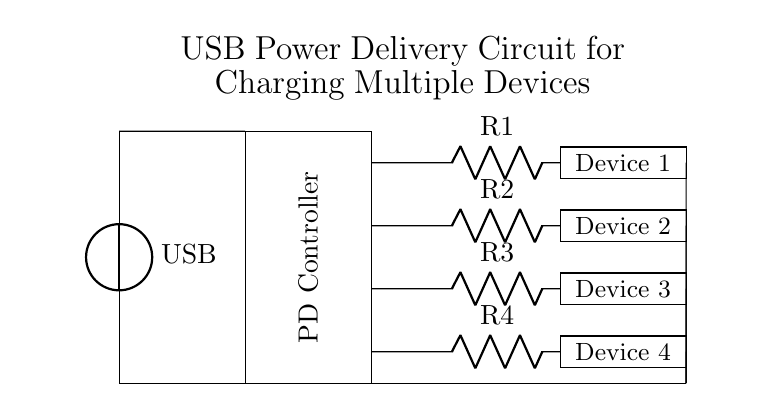What is the input source of this circuit? The input source is a USB voltage source, denoted as "USB" in the top left corner of the diagram.
Answer: USB How many devices can this circuit charge? The circuit diagram shows four labeled rectangles for devices, indicating that it can charge four devices simultaneously.
Answer: Four What type of controller is used in this circuit? The diagram shows a rectangle labeled "PD Controller," which indicates that a Power Delivery Controller is employed to manage power distribution among the devices.
Answer: PD Controller What is the purpose of the resistors in this circuit? The resistors (R1, R2, R3, and R4) likely limit current flowing to each device, ensuring that the devices receive appropriate power without overloading.
Answer: Limit current Which component is responsible for distributing power? The Power Delivery Controller, as shown in the center of the circuit, manages the distribution of power from the USB source to the devices.
Answer: Power Delivery Controller What connections are shown to ground in the circuit? The circuit features a common ground connection line that links the ground for the USB source and the ground points from each device.
Answer: Common ground connection What is the orientation of the USB power connection? The USB connection in the circuit is oriented vertically, as indicated by the "+" sign at the top representing the positive terminal of the voltage source.
Answer: Vertical 